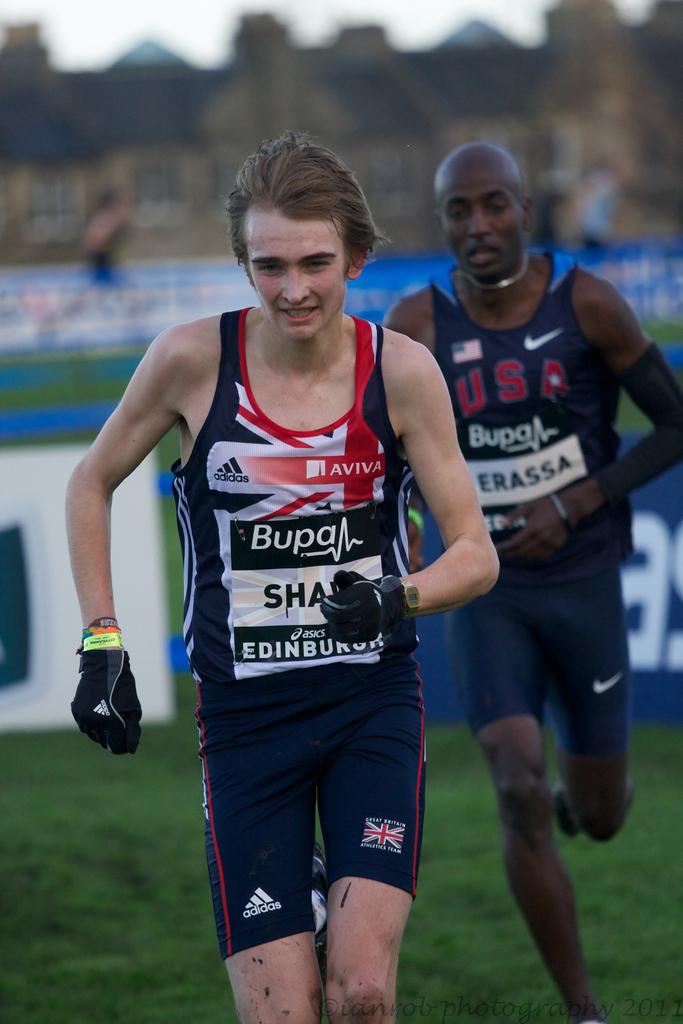What country is the guy in second from?
Provide a short and direct response. Usa. What is the town the man is first is from?
Make the answer very short. Edinburgh. 